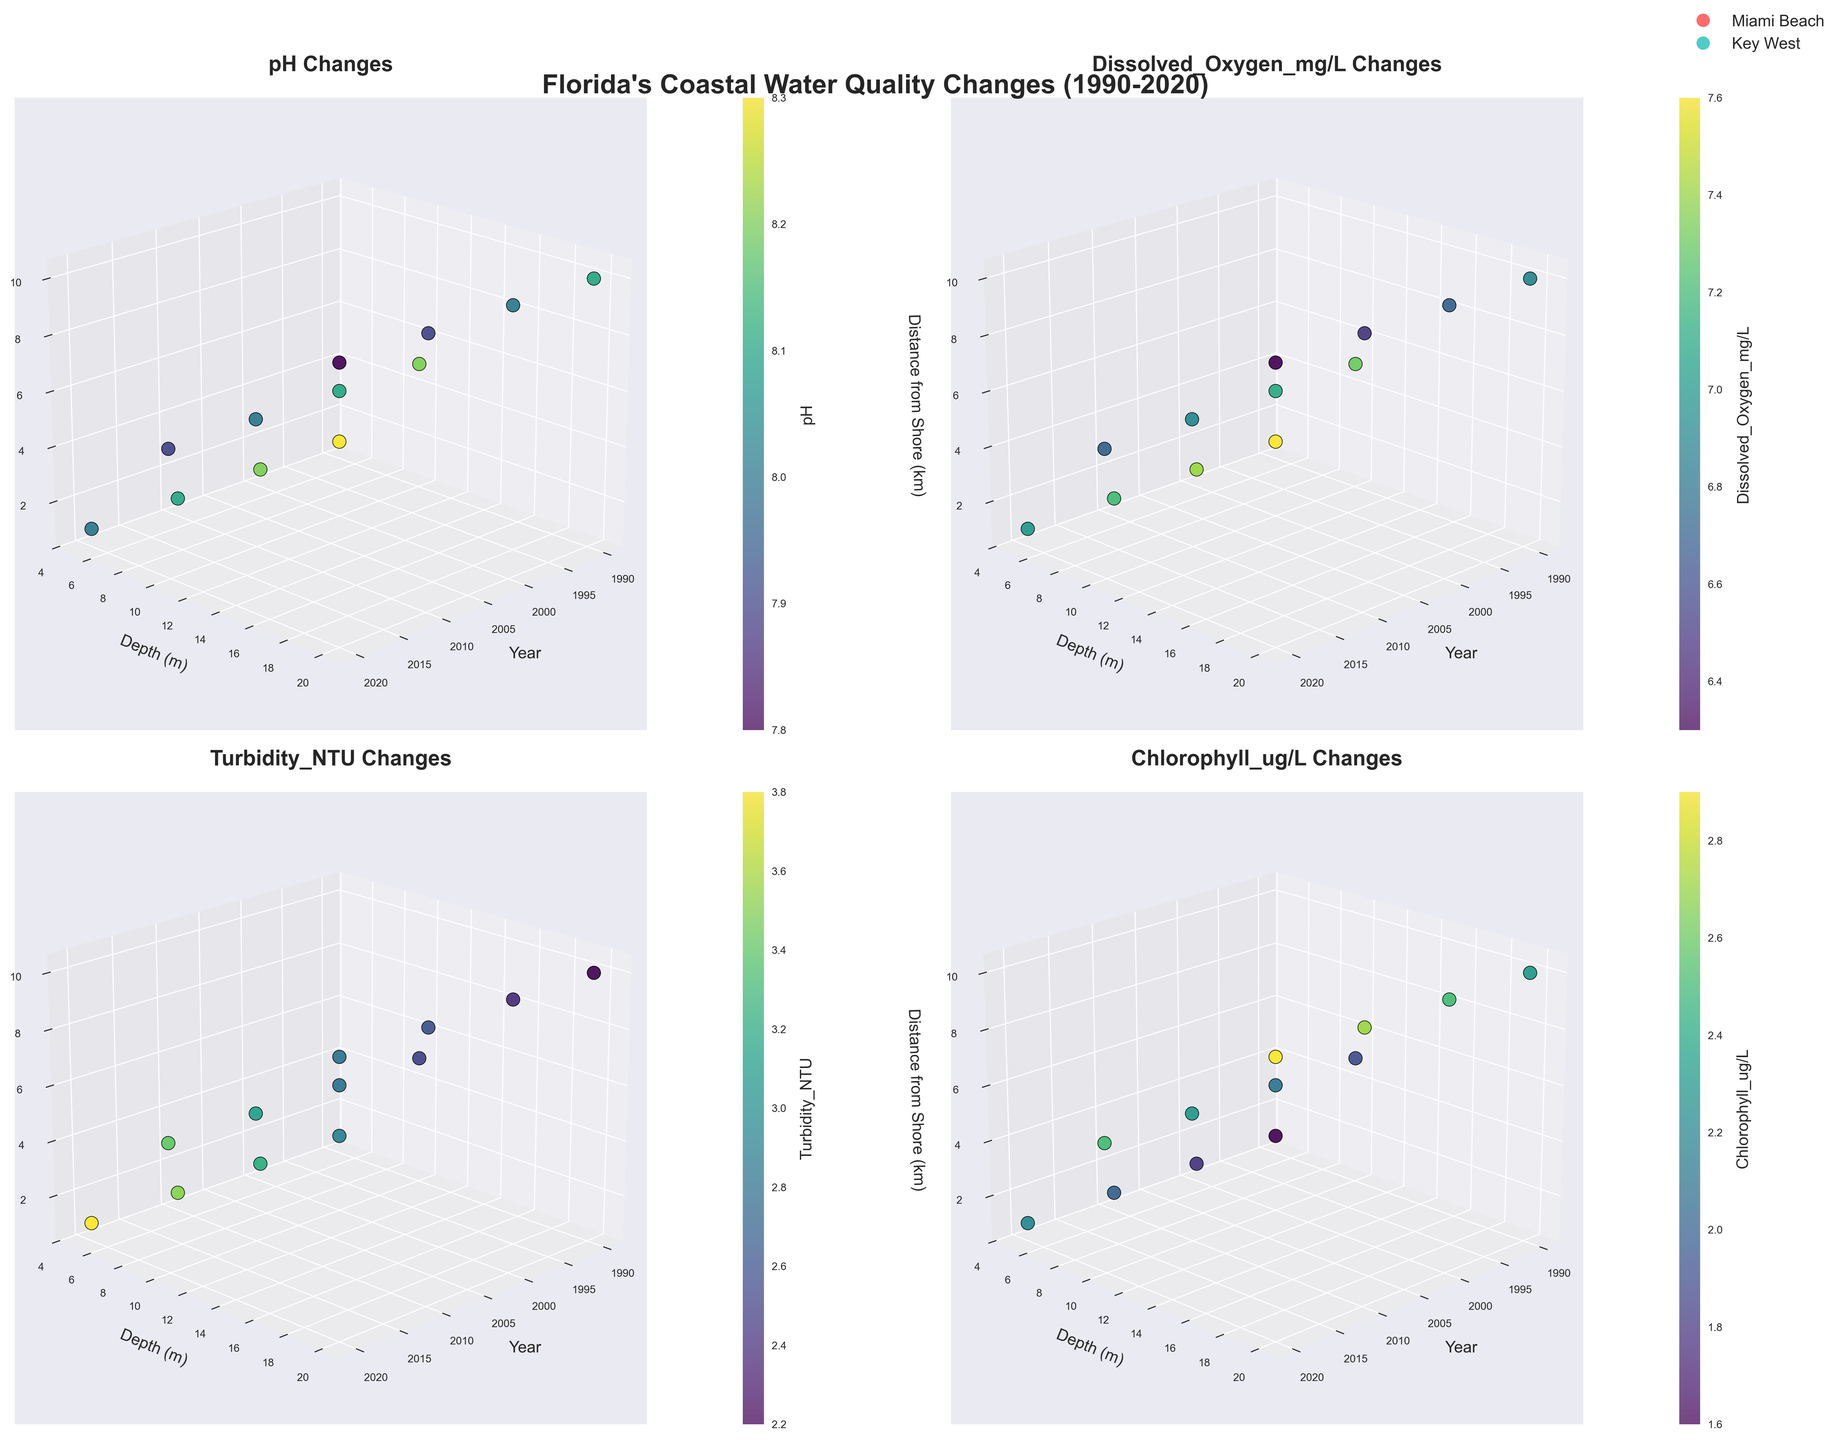What is the title of the figure? The title of the figure is usually at the top and provides a summary of what the figure represents. In this case, the title is "Florida's Coastal Water Quality Changes (1990-2020)" shown at the top center of the figure.
Answer: Florida's Coastal Water Quality Changes (1990-2020) Which parameter shows the most significant increase in value from 1990 to 2020 at a depth of 5 meters? To answer this, observe the parameter changes in the "5 meters" depth subplots for each parameter over the years from 1990 to 2020. Turbidity (NTU) shows a clear increase in both locations (Miami Beach and Key West).
Answer: Turbidity (NTU) How is the pH value trend over time at a depth of 20 meters? Look at the pH values at 20 meters depth across different years in both Miami Beach and Key West. The pH value shows a decreasing trend over time in both locations.
Answer: Decreasing In which year does Miami Beach have the highest dissolved oxygen (mg/L) value at 5 meters depth? Check the dissolved oxygen (mg/L) values at the depth of 5 meters for Miami Beach in various years in the 3D plot. The highest value of 7.5mg/L occurred in 1990.
Answer: 1990 What is the difference in chlorophyll (ug/L) values at a depth of 10 meters between Key West and Miami Beach in 2020? Compare the chlorophyll values in Key West and Miami Beach at the depth of 10 meters for the year 2020. Key West has 2.5 ug/L and Miami Beach has 2.7 ug/L. The difference is 2.7 - 2.5 = 0.2 ug/L.
Answer: 0.2 ug/L Which location shows a higher Turbidity (NTU) at 10 meters depth in 2000? Look at the Turbidity (NTU) values at 10 meters depth for both locations (Miami Beach and Key West) in the year 2000. Miami Beach has a higher value of 3.1 NTU compared to Key West's 2.8 NTU.
Answer: Miami Beach Is the trend of Dissolved Oxygen (mg/L) over time consistent across different depths in Key West? Analyze the trend lines for Dissolved Oxygen at different depths in Key West over various years. The trend in all depths shows a general decrease over the timeline from 1990 to 2020.
Answer: Yes Does Chlorophyll (ug/L) increase or decrease over time at a distance of 10 km from the shore in Miami Beach? Check the changes in Chlorophyll (ug/L) at the distance of 10 km from the shore for Miami Beach over the years. The values increase from 2.5 ug/L in 1990 to 3.1 ug/L in 2020.
Answer: Increase What is the most noticeable trend in the pH change in Key West between 1990 and 2020? Observe the pH values in Key West in different years. The pH shows a decreasing trend over time from 8.3 in 1990 to 7.8 in 2020.
Answer: Decreasing Which year and location combination shows the highest Chlorophyll (ug/L) value at 20 meters depth? Inspect the chlorophyll values at 20 meters depth for all years and locations. Miami Beach in 2020 has the highest value of 3.1 ug/L.
Answer: Miami Beach, 2020 